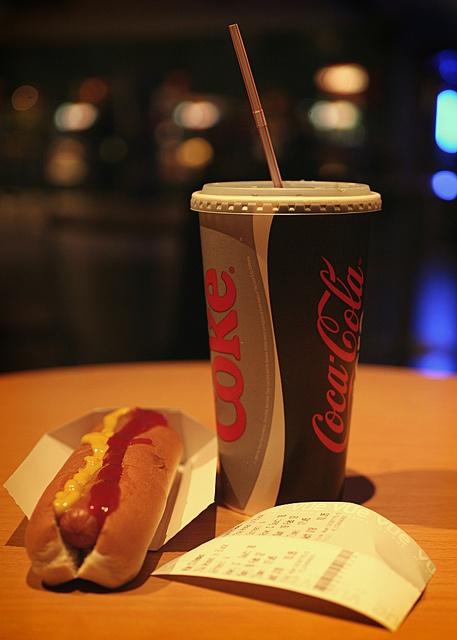Describe the objects in this image and their specific colors. I can see dining table in black, red, khaki, orange, and brown tones, cup in black, brown, and maroon tones, and hot dog in black, brown, red, and orange tones in this image. 